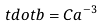Convert formula to latex. <formula><loc_0><loc_0><loc_500><loc_500>\ t d o t { b } = C a ^ { - 3 }</formula> 